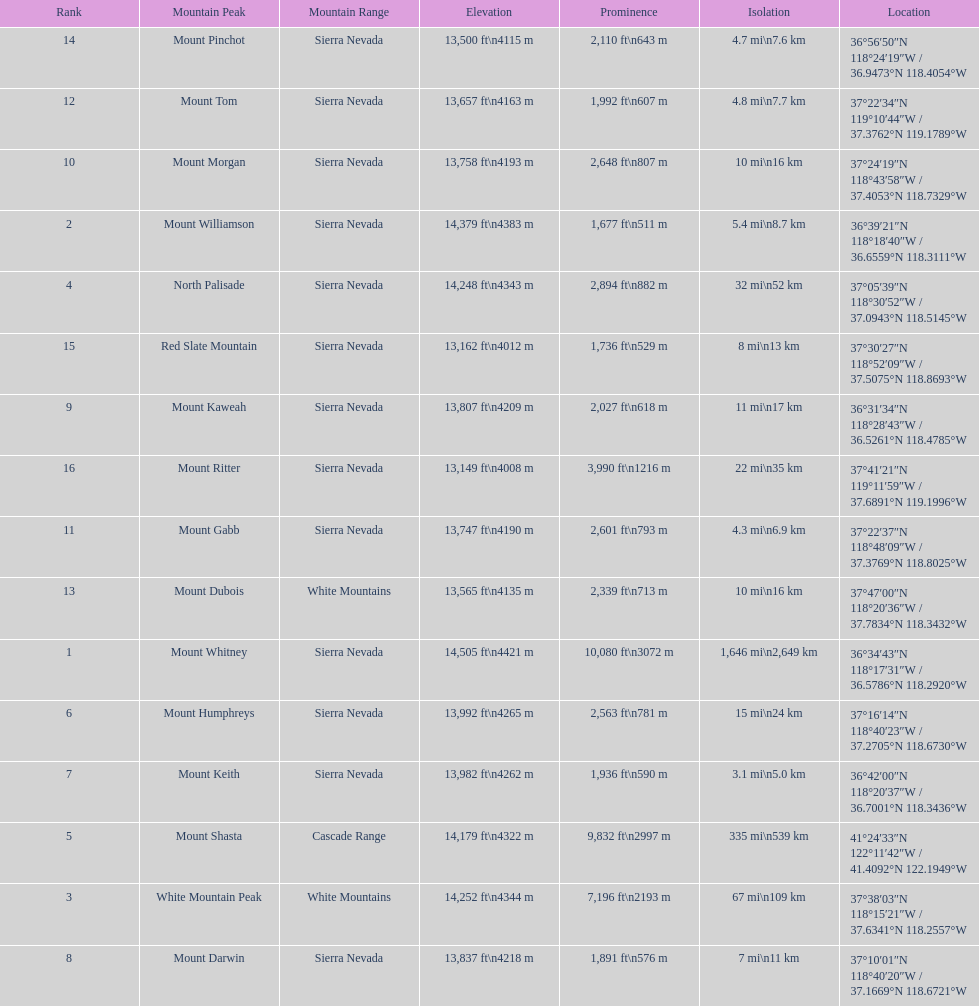Which mountain peak has the least isolation? Mount Keith. 